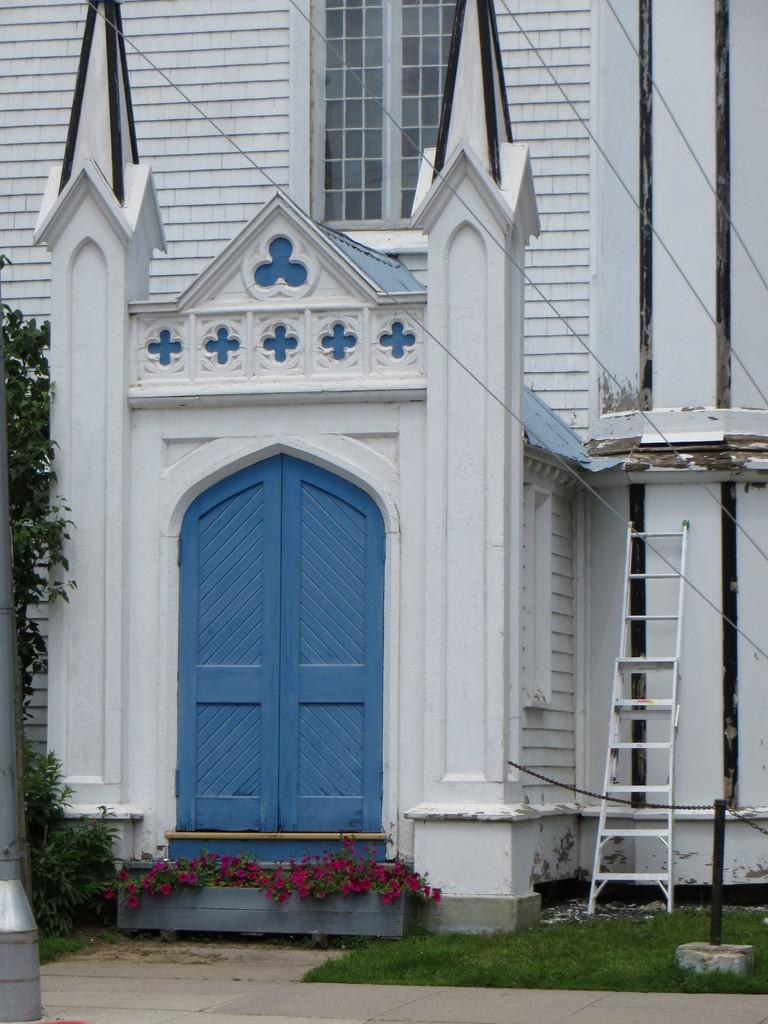What type of structure is visible in the image? There is a building in the image. What type of plant can be seen in the image? There is a potted plant in the image. What is the purpose of the ladder in the image? The ladder is likely used for reaching higher areas, but its specific purpose cannot be determined from the image alone. What is the pole used for in the image? The purpose of the pole cannot be determined from the image alone. What type of vegetation is present in the image? There are trees and grass in the image. How many basketballs are visible in the image? There are no basketballs present in the image. Can you see any planes flying in the image? There are no planes visible in the image. Are there any fairies visible in the image? There are no fairies present in the image. 